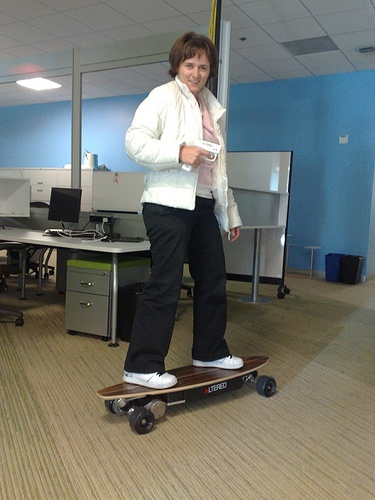Describe the objects in this image and their specific colors. I can see people in gray, black, white, and darkgray tones, skateboard in gray, black, and maroon tones, tv in gray, black, and darkgray tones, and keyboard in gray and black tones in this image. 